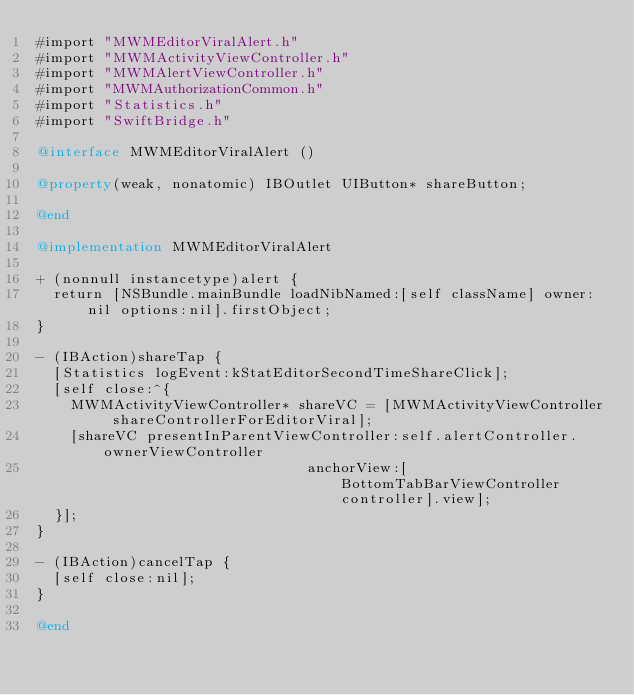<code> <loc_0><loc_0><loc_500><loc_500><_ObjectiveC_>#import "MWMEditorViralAlert.h"
#import "MWMActivityViewController.h"
#import "MWMAlertViewController.h"
#import "MWMAuthorizationCommon.h"
#import "Statistics.h"
#import "SwiftBridge.h"

@interface MWMEditorViralAlert ()

@property(weak, nonatomic) IBOutlet UIButton* shareButton;

@end

@implementation MWMEditorViralAlert

+ (nonnull instancetype)alert {
  return [NSBundle.mainBundle loadNibNamed:[self className] owner:nil options:nil].firstObject;
}

- (IBAction)shareTap {
  [Statistics logEvent:kStatEditorSecondTimeShareClick];
  [self close:^{
    MWMActivityViewController* shareVC = [MWMActivityViewController shareControllerForEditorViral];
    [shareVC presentInParentViewController:self.alertController.ownerViewController
                                anchorView:[BottomTabBarViewController controller].view];
  }];
}

- (IBAction)cancelTap {
  [self close:nil];
}

@end
</code> 